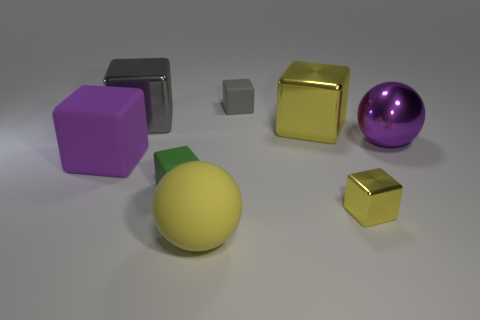How many objects are small matte things or big red cylinders?
Give a very brief answer. 2. What is the color of the metallic sphere that is the same size as the purple rubber object?
Offer a very short reply. Purple. How many objects are balls that are in front of the big purple cube or big purple rubber cubes?
Your answer should be very brief. 2. How many other things are there of the same size as the purple metal sphere?
Your answer should be very brief. 4. There is a yellow metallic object that is behind the tiny yellow block; what size is it?
Provide a short and direct response. Large. What is the shape of the purple thing that is the same material as the yellow ball?
Offer a terse response. Cube. Is there any other thing that is the same color as the large rubber cube?
Ensure brevity in your answer.  Yes. There is a tiny matte thing that is on the right side of the small rubber thing that is in front of the gray metal cube; what is its color?
Your answer should be compact. Gray. What number of tiny things are either green rubber blocks or brown matte balls?
Provide a succinct answer. 1. What material is the other tiny gray object that is the same shape as the gray metallic thing?
Your answer should be very brief. Rubber. 